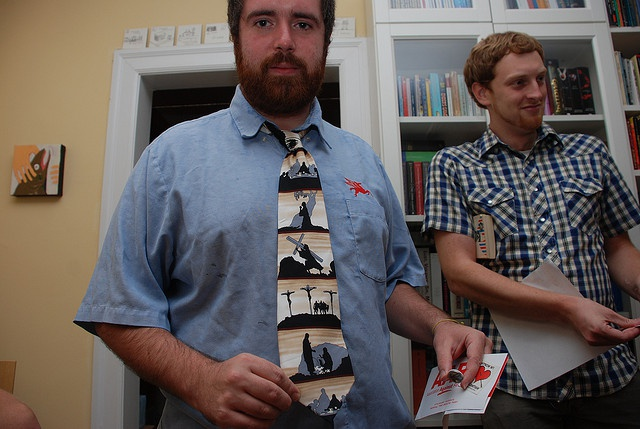Describe the objects in this image and their specific colors. I can see people in gray and black tones, people in gray, black, maroon, and brown tones, tie in gray, black, and darkgray tones, book in gray, darkgray, and black tones, and book in gray, black, and maroon tones in this image. 